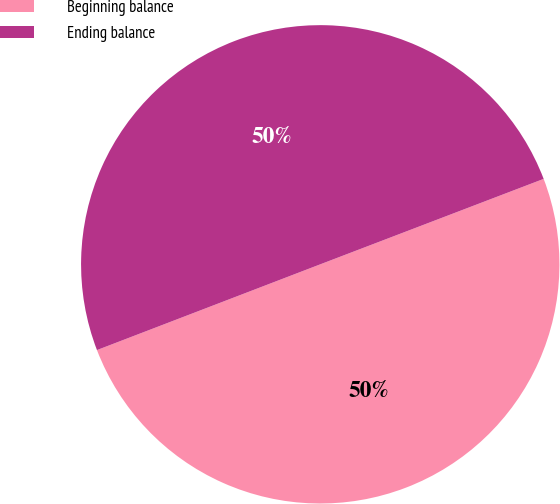Convert chart. <chart><loc_0><loc_0><loc_500><loc_500><pie_chart><fcel>Beginning balance<fcel>Ending balance<nl><fcel>49.98%<fcel>50.02%<nl></chart> 